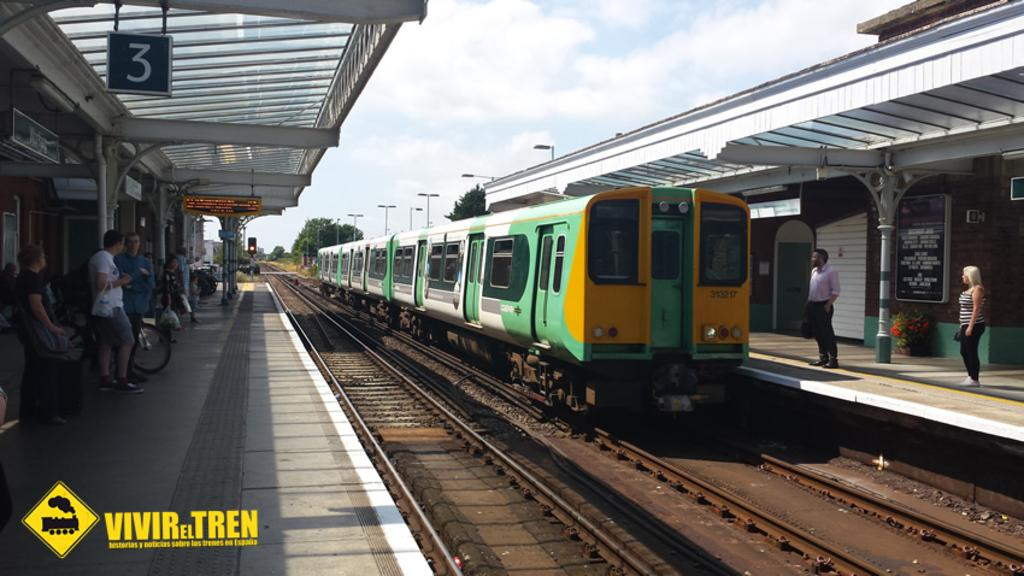<image>
Relay a brief, clear account of the picture shown. A train at a station opposite a sign indicating it is platform 3. 